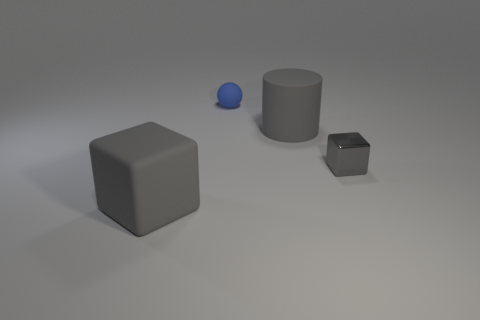Add 2 tiny yellow shiny cylinders. How many objects exist? 6 Subtract 1 cubes. How many cubes are left? 1 Add 4 tiny blue metallic objects. How many tiny blue metallic objects exist? 4 Subtract 0 blue cubes. How many objects are left? 4 Subtract all cylinders. How many objects are left? 3 Subtract all yellow spheres. Subtract all gray cylinders. How many spheres are left? 1 Subtract all big blue shiny cubes. Subtract all small gray metal cubes. How many objects are left? 3 Add 3 big objects. How many big objects are left? 5 